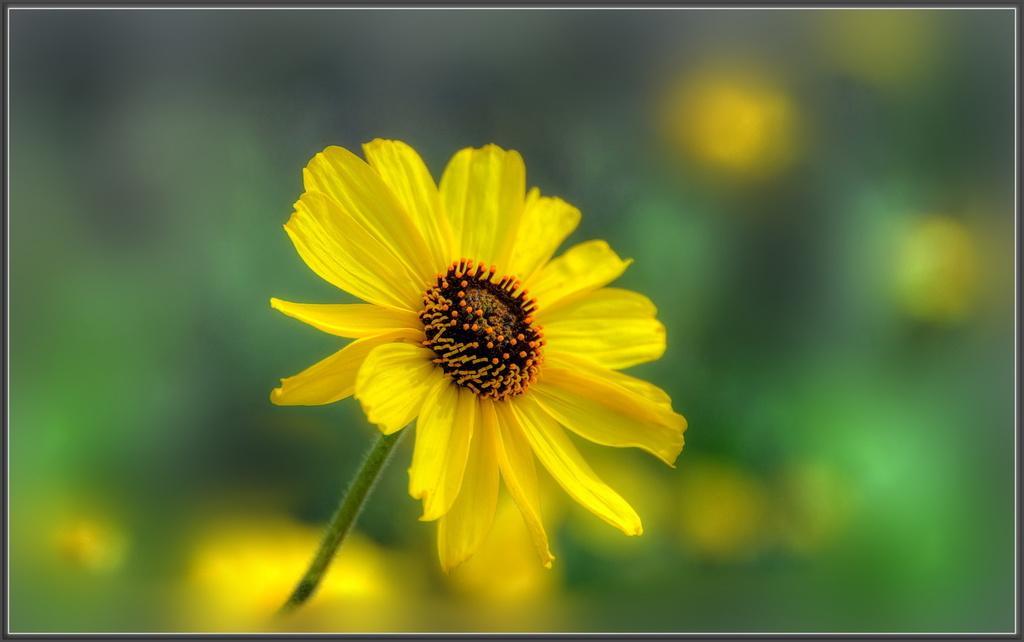Please provide a concise description of this image. In the image we can see there is a sunflower and background of the image is blurred. 